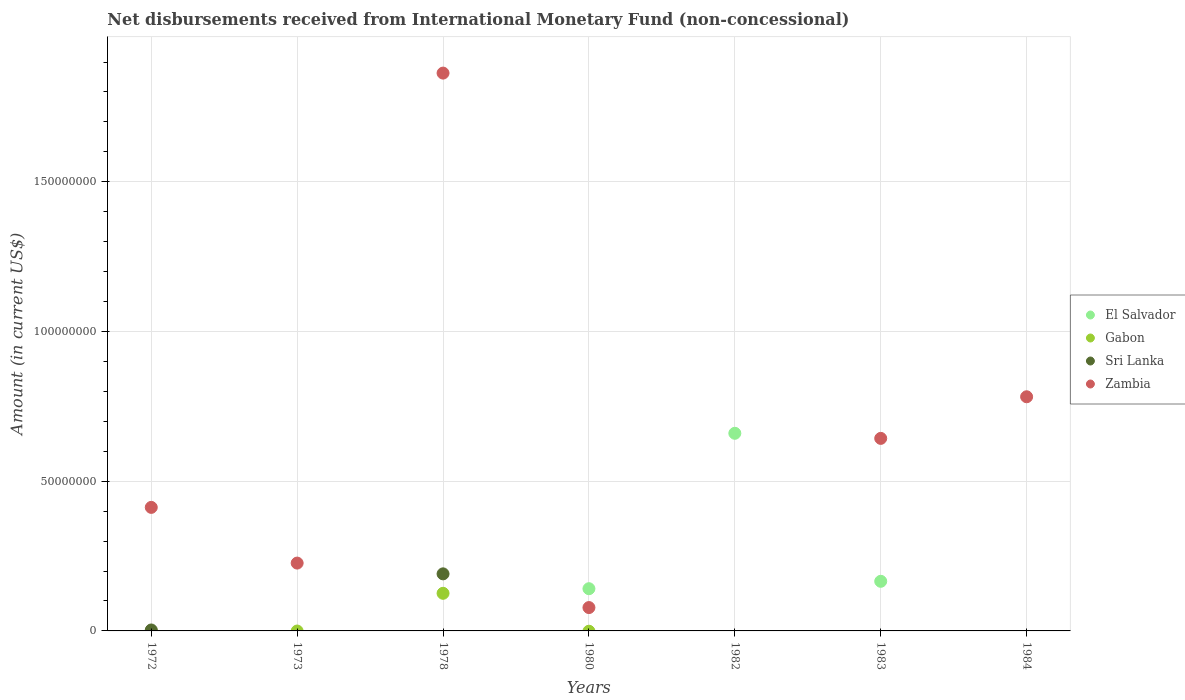Is the number of dotlines equal to the number of legend labels?
Provide a short and direct response. No. What is the amount of disbursements received from International Monetary Fund in Gabon in 1972?
Make the answer very short. 0. Across all years, what is the maximum amount of disbursements received from International Monetary Fund in El Salvador?
Keep it short and to the point. 6.60e+07. In which year was the amount of disbursements received from International Monetary Fund in Zambia maximum?
Make the answer very short. 1978. What is the total amount of disbursements received from International Monetary Fund in El Salvador in the graph?
Offer a very short reply. 9.67e+07. What is the difference between the amount of disbursements received from International Monetary Fund in El Salvador in 1980 and that in 1982?
Your answer should be compact. -5.19e+07. What is the difference between the amount of disbursements received from International Monetary Fund in El Salvador in 1978 and the amount of disbursements received from International Monetary Fund in Gabon in 1982?
Give a very brief answer. 0. What is the average amount of disbursements received from International Monetary Fund in Sri Lanka per year?
Offer a very short reply. 2.77e+06. In how many years, is the amount of disbursements received from International Monetary Fund in Zambia greater than 120000000 US$?
Your response must be concise. 1. What is the ratio of the amount of disbursements received from International Monetary Fund in Zambia in 1972 to that in 1973?
Offer a very short reply. 1.82. Is the amount of disbursements received from International Monetary Fund in Zambia in 1983 less than that in 1984?
Give a very brief answer. Yes. What is the difference between the highest and the second highest amount of disbursements received from International Monetary Fund in Zambia?
Your answer should be very brief. 1.08e+08. What is the difference between the highest and the lowest amount of disbursements received from International Monetary Fund in Zambia?
Provide a succinct answer. 1.86e+08. In how many years, is the amount of disbursements received from International Monetary Fund in Zambia greater than the average amount of disbursements received from International Monetary Fund in Zambia taken over all years?
Keep it short and to the point. 3. Is it the case that in every year, the sum of the amount of disbursements received from International Monetary Fund in Sri Lanka and amount of disbursements received from International Monetary Fund in Gabon  is greater than the sum of amount of disbursements received from International Monetary Fund in El Salvador and amount of disbursements received from International Monetary Fund in Zambia?
Make the answer very short. No. Is the amount of disbursements received from International Monetary Fund in Gabon strictly less than the amount of disbursements received from International Monetary Fund in El Salvador over the years?
Provide a short and direct response. No. How many years are there in the graph?
Your response must be concise. 7. How are the legend labels stacked?
Provide a short and direct response. Vertical. What is the title of the graph?
Keep it short and to the point. Net disbursements received from International Monetary Fund (non-concessional). What is the label or title of the Y-axis?
Your response must be concise. Amount (in current US$). What is the Amount (in current US$) in Sri Lanka in 1972?
Keep it short and to the point. 3.15e+05. What is the Amount (in current US$) of Zambia in 1972?
Ensure brevity in your answer.  4.13e+07. What is the Amount (in current US$) in El Salvador in 1973?
Your answer should be compact. 0. What is the Amount (in current US$) of Zambia in 1973?
Your response must be concise. 2.27e+07. What is the Amount (in current US$) of El Salvador in 1978?
Provide a succinct answer. 0. What is the Amount (in current US$) of Gabon in 1978?
Ensure brevity in your answer.  1.26e+07. What is the Amount (in current US$) in Sri Lanka in 1978?
Your answer should be very brief. 1.91e+07. What is the Amount (in current US$) in Zambia in 1978?
Offer a very short reply. 1.86e+08. What is the Amount (in current US$) in El Salvador in 1980?
Your answer should be very brief. 1.41e+07. What is the Amount (in current US$) of Zambia in 1980?
Your answer should be compact. 7.80e+06. What is the Amount (in current US$) in El Salvador in 1982?
Offer a very short reply. 6.60e+07. What is the Amount (in current US$) of Gabon in 1982?
Your answer should be very brief. 0. What is the Amount (in current US$) in Zambia in 1982?
Your answer should be compact. 0. What is the Amount (in current US$) of El Salvador in 1983?
Give a very brief answer. 1.66e+07. What is the Amount (in current US$) in Zambia in 1983?
Give a very brief answer. 6.43e+07. What is the Amount (in current US$) of Gabon in 1984?
Provide a short and direct response. 0. What is the Amount (in current US$) of Zambia in 1984?
Provide a succinct answer. 7.82e+07. Across all years, what is the maximum Amount (in current US$) in El Salvador?
Provide a succinct answer. 6.60e+07. Across all years, what is the maximum Amount (in current US$) in Gabon?
Offer a terse response. 1.26e+07. Across all years, what is the maximum Amount (in current US$) in Sri Lanka?
Make the answer very short. 1.91e+07. Across all years, what is the maximum Amount (in current US$) in Zambia?
Your answer should be compact. 1.86e+08. Across all years, what is the minimum Amount (in current US$) in Zambia?
Your response must be concise. 0. What is the total Amount (in current US$) in El Salvador in the graph?
Keep it short and to the point. 9.67e+07. What is the total Amount (in current US$) of Gabon in the graph?
Provide a succinct answer. 1.26e+07. What is the total Amount (in current US$) of Sri Lanka in the graph?
Your answer should be compact. 1.94e+07. What is the total Amount (in current US$) in Zambia in the graph?
Provide a short and direct response. 4.01e+08. What is the difference between the Amount (in current US$) of Zambia in 1972 and that in 1973?
Your answer should be compact. 1.86e+07. What is the difference between the Amount (in current US$) in Sri Lanka in 1972 and that in 1978?
Give a very brief answer. -1.87e+07. What is the difference between the Amount (in current US$) in Zambia in 1972 and that in 1978?
Keep it short and to the point. -1.45e+08. What is the difference between the Amount (in current US$) in Zambia in 1972 and that in 1980?
Offer a terse response. 3.35e+07. What is the difference between the Amount (in current US$) of Zambia in 1972 and that in 1983?
Give a very brief answer. -2.30e+07. What is the difference between the Amount (in current US$) in Zambia in 1972 and that in 1984?
Provide a short and direct response. -3.69e+07. What is the difference between the Amount (in current US$) of Zambia in 1973 and that in 1978?
Offer a very short reply. -1.64e+08. What is the difference between the Amount (in current US$) of Zambia in 1973 and that in 1980?
Make the answer very short. 1.49e+07. What is the difference between the Amount (in current US$) of Zambia in 1973 and that in 1983?
Your response must be concise. -4.16e+07. What is the difference between the Amount (in current US$) of Zambia in 1973 and that in 1984?
Make the answer very short. -5.55e+07. What is the difference between the Amount (in current US$) in Zambia in 1978 and that in 1980?
Offer a very short reply. 1.78e+08. What is the difference between the Amount (in current US$) in Zambia in 1978 and that in 1983?
Provide a succinct answer. 1.22e+08. What is the difference between the Amount (in current US$) in Zambia in 1978 and that in 1984?
Keep it short and to the point. 1.08e+08. What is the difference between the Amount (in current US$) in El Salvador in 1980 and that in 1982?
Keep it short and to the point. -5.19e+07. What is the difference between the Amount (in current US$) of El Salvador in 1980 and that in 1983?
Your response must be concise. -2.47e+06. What is the difference between the Amount (in current US$) in Zambia in 1980 and that in 1983?
Provide a succinct answer. -5.65e+07. What is the difference between the Amount (in current US$) of Zambia in 1980 and that in 1984?
Keep it short and to the point. -7.04e+07. What is the difference between the Amount (in current US$) in El Salvador in 1982 and that in 1983?
Offer a terse response. 4.94e+07. What is the difference between the Amount (in current US$) of Zambia in 1983 and that in 1984?
Keep it short and to the point. -1.39e+07. What is the difference between the Amount (in current US$) in Sri Lanka in 1972 and the Amount (in current US$) in Zambia in 1973?
Give a very brief answer. -2.23e+07. What is the difference between the Amount (in current US$) in Sri Lanka in 1972 and the Amount (in current US$) in Zambia in 1978?
Provide a succinct answer. -1.86e+08. What is the difference between the Amount (in current US$) of Sri Lanka in 1972 and the Amount (in current US$) of Zambia in 1980?
Give a very brief answer. -7.48e+06. What is the difference between the Amount (in current US$) in Sri Lanka in 1972 and the Amount (in current US$) in Zambia in 1983?
Offer a very short reply. -6.40e+07. What is the difference between the Amount (in current US$) in Sri Lanka in 1972 and the Amount (in current US$) in Zambia in 1984?
Provide a short and direct response. -7.79e+07. What is the difference between the Amount (in current US$) in Gabon in 1978 and the Amount (in current US$) in Zambia in 1980?
Provide a succinct answer. 4.76e+06. What is the difference between the Amount (in current US$) in Sri Lanka in 1978 and the Amount (in current US$) in Zambia in 1980?
Provide a short and direct response. 1.13e+07. What is the difference between the Amount (in current US$) in Gabon in 1978 and the Amount (in current US$) in Zambia in 1983?
Make the answer very short. -5.17e+07. What is the difference between the Amount (in current US$) of Sri Lanka in 1978 and the Amount (in current US$) of Zambia in 1983?
Offer a very short reply. -4.52e+07. What is the difference between the Amount (in current US$) of Gabon in 1978 and the Amount (in current US$) of Zambia in 1984?
Offer a terse response. -6.56e+07. What is the difference between the Amount (in current US$) in Sri Lanka in 1978 and the Amount (in current US$) in Zambia in 1984?
Provide a succinct answer. -5.91e+07. What is the difference between the Amount (in current US$) in El Salvador in 1980 and the Amount (in current US$) in Zambia in 1983?
Provide a succinct answer. -5.02e+07. What is the difference between the Amount (in current US$) in El Salvador in 1980 and the Amount (in current US$) in Zambia in 1984?
Your answer should be compact. -6.41e+07. What is the difference between the Amount (in current US$) of El Salvador in 1982 and the Amount (in current US$) of Zambia in 1983?
Offer a terse response. 1.70e+06. What is the difference between the Amount (in current US$) in El Salvador in 1982 and the Amount (in current US$) in Zambia in 1984?
Provide a short and direct response. -1.22e+07. What is the difference between the Amount (in current US$) in El Salvador in 1983 and the Amount (in current US$) in Zambia in 1984?
Your answer should be compact. -6.16e+07. What is the average Amount (in current US$) in El Salvador per year?
Give a very brief answer. 1.38e+07. What is the average Amount (in current US$) of Gabon per year?
Make the answer very short. 1.79e+06. What is the average Amount (in current US$) of Sri Lanka per year?
Provide a short and direct response. 2.77e+06. What is the average Amount (in current US$) of Zambia per year?
Your answer should be compact. 5.72e+07. In the year 1972, what is the difference between the Amount (in current US$) of Sri Lanka and Amount (in current US$) of Zambia?
Give a very brief answer. -4.09e+07. In the year 1978, what is the difference between the Amount (in current US$) in Gabon and Amount (in current US$) in Sri Lanka?
Offer a terse response. -6.50e+06. In the year 1978, what is the difference between the Amount (in current US$) of Gabon and Amount (in current US$) of Zambia?
Offer a very short reply. -1.74e+08. In the year 1978, what is the difference between the Amount (in current US$) of Sri Lanka and Amount (in current US$) of Zambia?
Make the answer very short. -1.67e+08. In the year 1980, what is the difference between the Amount (in current US$) of El Salvador and Amount (in current US$) of Zambia?
Ensure brevity in your answer.  6.30e+06. In the year 1983, what is the difference between the Amount (in current US$) of El Salvador and Amount (in current US$) of Zambia?
Offer a very short reply. -4.77e+07. What is the ratio of the Amount (in current US$) of Zambia in 1972 to that in 1973?
Your answer should be compact. 1.82. What is the ratio of the Amount (in current US$) of Sri Lanka in 1972 to that in 1978?
Provide a succinct answer. 0.02. What is the ratio of the Amount (in current US$) in Zambia in 1972 to that in 1978?
Your answer should be very brief. 0.22. What is the ratio of the Amount (in current US$) in Zambia in 1972 to that in 1980?
Give a very brief answer. 5.29. What is the ratio of the Amount (in current US$) of Zambia in 1972 to that in 1983?
Ensure brevity in your answer.  0.64. What is the ratio of the Amount (in current US$) of Zambia in 1972 to that in 1984?
Keep it short and to the point. 0.53. What is the ratio of the Amount (in current US$) of Zambia in 1973 to that in 1978?
Keep it short and to the point. 0.12. What is the ratio of the Amount (in current US$) of Zambia in 1973 to that in 1980?
Provide a succinct answer. 2.9. What is the ratio of the Amount (in current US$) in Zambia in 1973 to that in 1983?
Your answer should be compact. 0.35. What is the ratio of the Amount (in current US$) of Zambia in 1973 to that in 1984?
Keep it short and to the point. 0.29. What is the ratio of the Amount (in current US$) in Zambia in 1978 to that in 1980?
Give a very brief answer. 23.88. What is the ratio of the Amount (in current US$) in Zambia in 1978 to that in 1983?
Ensure brevity in your answer.  2.9. What is the ratio of the Amount (in current US$) in Zambia in 1978 to that in 1984?
Offer a very short reply. 2.38. What is the ratio of the Amount (in current US$) in El Salvador in 1980 to that in 1982?
Offer a terse response. 0.21. What is the ratio of the Amount (in current US$) of El Salvador in 1980 to that in 1983?
Your answer should be very brief. 0.85. What is the ratio of the Amount (in current US$) of Zambia in 1980 to that in 1983?
Keep it short and to the point. 0.12. What is the ratio of the Amount (in current US$) in Zambia in 1980 to that in 1984?
Offer a terse response. 0.1. What is the ratio of the Amount (in current US$) of El Salvador in 1982 to that in 1983?
Your response must be concise. 3.98. What is the ratio of the Amount (in current US$) of Zambia in 1983 to that in 1984?
Ensure brevity in your answer.  0.82. What is the difference between the highest and the second highest Amount (in current US$) of El Salvador?
Your answer should be very brief. 4.94e+07. What is the difference between the highest and the second highest Amount (in current US$) in Zambia?
Your answer should be compact. 1.08e+08. What is the difference between the highest and the lowest Amount (in current US$) of El Salvador?
Make the answer very short. 6.60e+07. What is the difference between the highest and the lowest Amount (in current US$) of Gabon?
Your answer should be compact. 1.26e+07. What is the difference between the highest and the lowest Amount (in current US$) in Sri Lanka?
Offer a very short reply. 1.91e+07. What is the difference between the highest and the lowest Amount (in current US$) in Zambia?
Provide a succinct answer. 1.86e+08. 